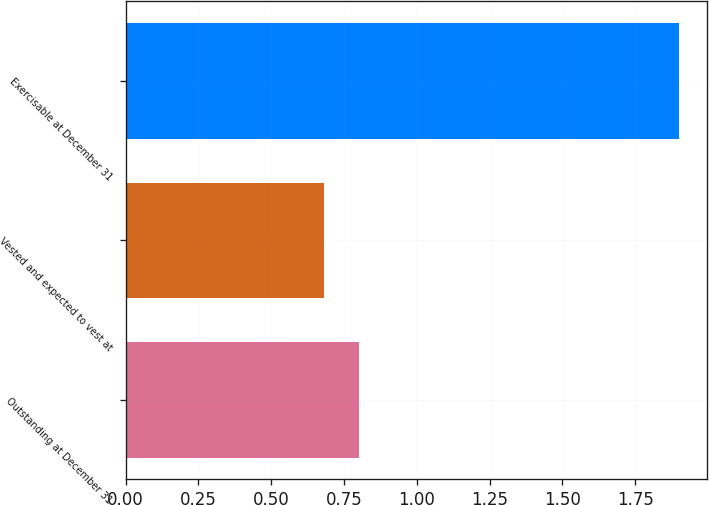Convert chart. <chart><loc_0><loc_0><loc_500><loc_500><bar_chart><fcel>Outstanding at December 31<fcel>Vested and expected to vest at<fcel>Exercisable at December 31<nl><fcel>0.8<fcel>0.68<fcel>1.9<nl></chart> 